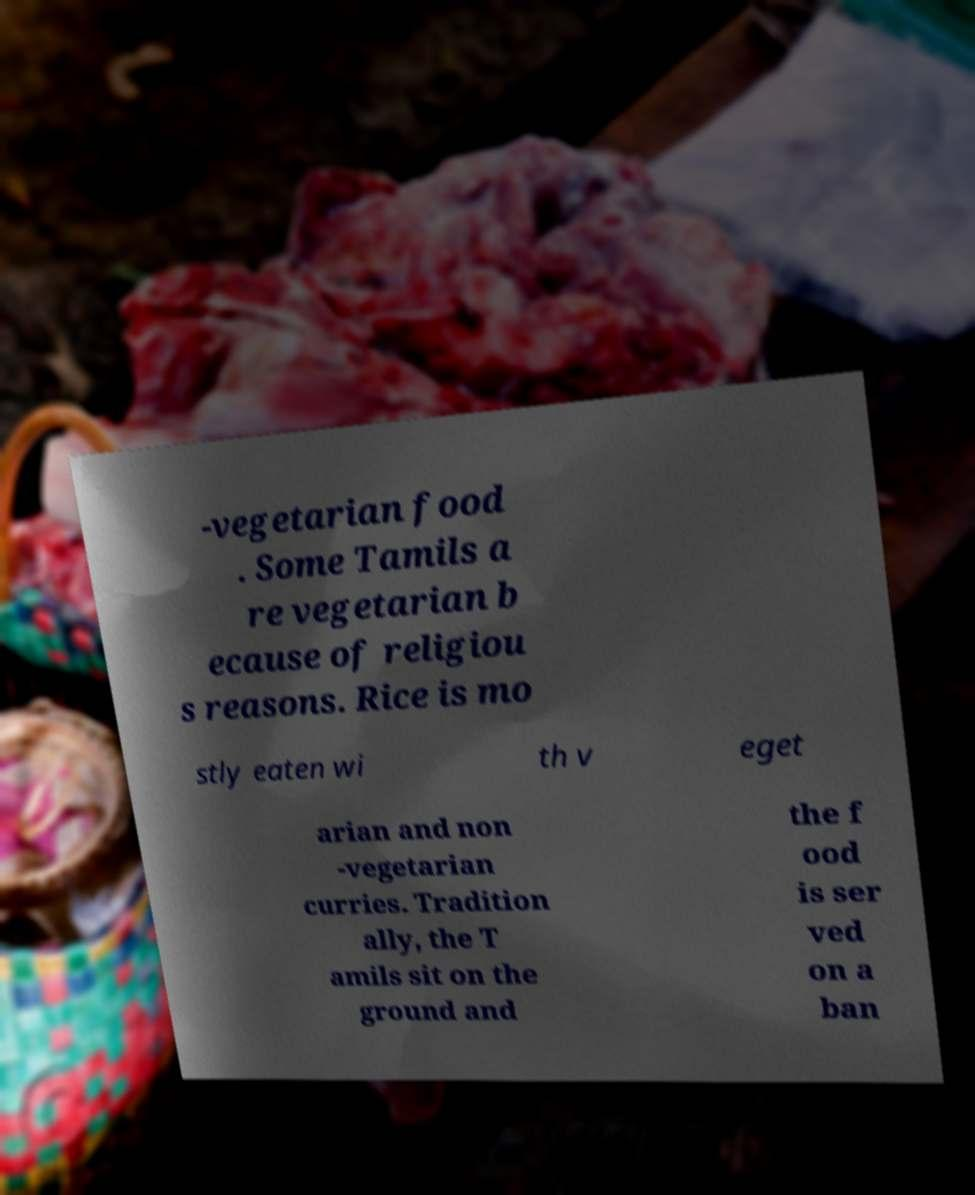Please read and relay the text visible in this image. What does it say? -vegetarian food . Some Tamils a re vegetarian b ecause of religiou s reasons. Rice is mo stly eaten wi th v eget arian and non -vegetarian curries. Tradition ally, the T amils sit on the ground and the f ood is ser ved on a ban 